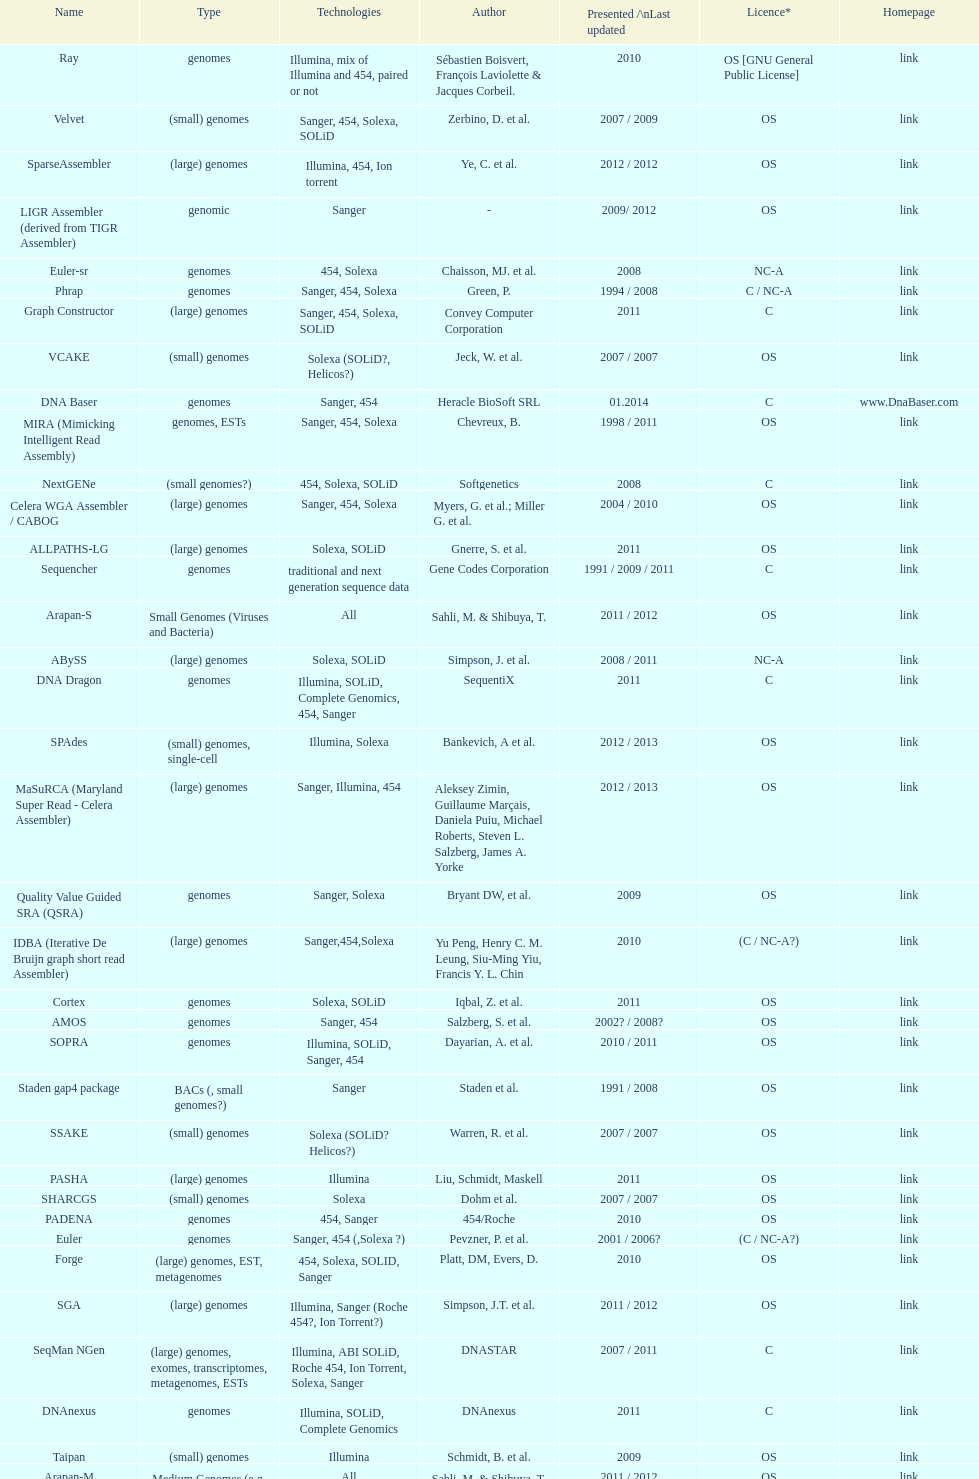How many are listed as "all" technologies? 2. 